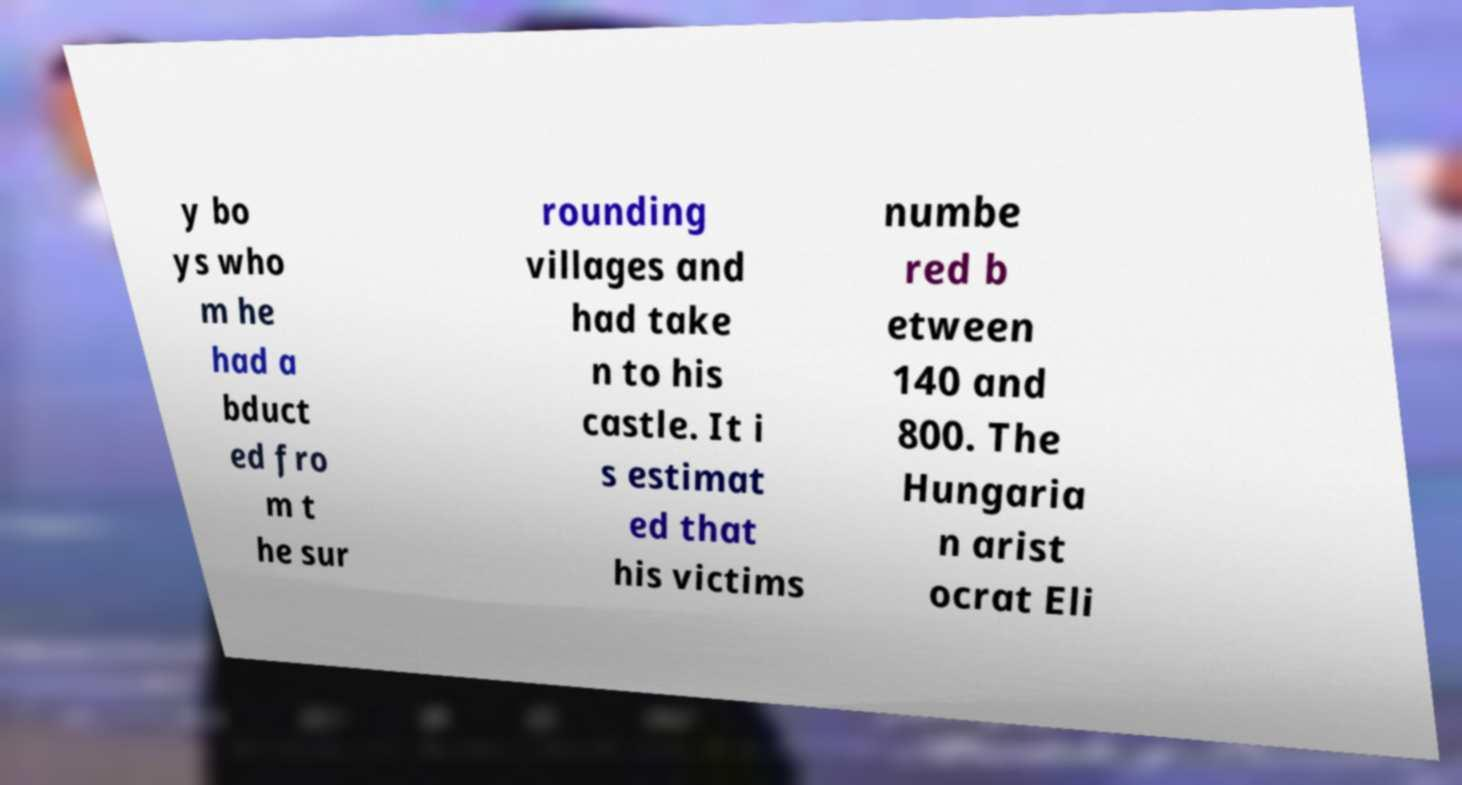For documentation purposes, I need the text within this image transcribed. Could you provide that? y bo ys who m he had a bduct ed fro m t he sur rounding villages and had take n to his castle. It i s estimat ed that his victims numbe red b etween 140 and 800. The Hungaria n arist ocrat Eli 